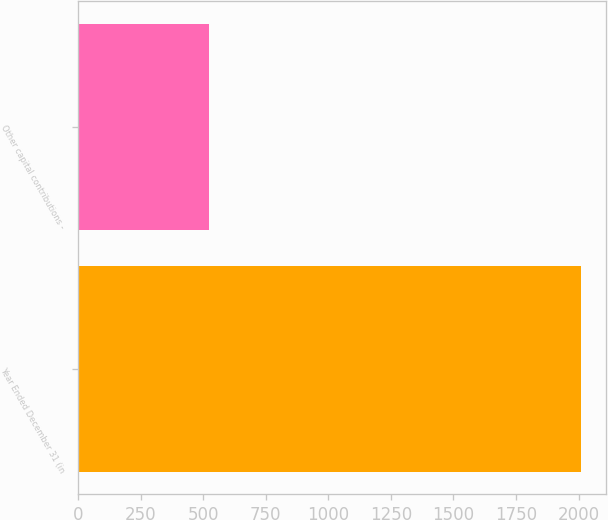<chart> <loc_0><loc_0><loc_500><loc_500><bar_chart><fcel>Year Ended December 31 (in<fcel>Other capital contributions -<nl><fcel>2011<fcel>523<nl></chart> 